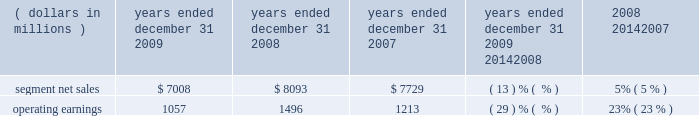Management 2019s discussion and analysis of financial condition and results of operations in 2008 , sales to the segment 2019s top five customers represented approximately 45% ( 45 % ) of the segment 2019s net sales .
The segment 2019s backlog was $ 2.3 billion at december 31 , 2008 , compared to $ 2.6 billion at december 31 , 2007 .
In 2008 , our digital video customers significantly increased their purchases of the segment 2019s products and services , primarily due to increased demand for digital entertainment devices , particularly ip and hd/dvr devices .
In february 2008 , the segment acquired the assets related to digital cable set-top products of zhejiang dahua digital technology co. , ltd and hangzhou image silicon ( known collectively as dahua digital ) , a developer , manufacturer and marketer of cable set-tops and related low-cost integrated circuits for the emerging chinese cable business .
The acquisition helped the segment strengthen its position in the rapidly growing cable market in china .
Enterprise mobility solutions segment the enterprise mobility solutions segment designs , manufactures , sells , installs and services analog and digital two-way radios , wireless lan and security products , voice and data communications products and systems for private networks , wireless broadband systems and end-to-end enterprise mobility solutions to a wide range of customers , including government and public safety agencies ( which , together with all sales to distributors of two-way communication products , are referred to as the 2018 2018government and public safety market 2019 2019 ) , as well as retail , energy and utilities , transportation , manufacturing , healthcare and other commercial customers ( which , collectively , are referred to as the 2018 2018commercial enterprise market 2019 2019 ) .
In 2009 , the segment 2019s net sales represented 32% ( 32 % ) of the company 2019s consolidated net sales , compared to 27% ( 27 % ) in 2008 and 21% ( 21 % ) in 2007 .
Years ended december 31 percent change ( dollars in millions ) 2009 2008 2007 2009 20142008 2008 20142007 .
Segment results 20142009 compared to 2008 in 2009 , the segment 2019s net sales were $ 7.0 billion , a decrease of 13% ( 13 % ) compared to net sales of $ 8.1 billion in 2008 .
The 13% ( 13 % ) decrease in net sales reflects a 21% ( 21 % ) decrease in net sales to the commercial enterprise market and a 10% ( 10 % ) decrease in net sales to the government and public safety market .
The decrease in net sales to the commercial enterprise market reflects decreased net sales in all regions .
The decrease in net sales to the government and public safety market was primarily driven by decreased net sales in emea , north america and latin america , partially offset by higher net sales in asia .
The segment 2019s overall net sales were lower in north america , emea and latin america and higher in asia the segment had operating earnings of $ 1.1 billion in 2009 , a decrease of 29% ( 29 % ) compared to operating earnings of $ 1.5 billion in 2008 .
The decrease in operating earnings was primarily due to a decrease in gross margin , driven by the 13% ( 13 % ) decrease in net sales and an unfavorable product mix .
Also contributing to the decrease in operating earnings was an increase in reorganization of business charges , relating primarily to higher employee severance costs .
These factors were partially offset by decreased sg&a expenses and r&d expenditures , primarily related to savings from cost-reduction initiatives .
As a percentage of net sales in 2009 as compared 2008 , gross margin decreased and r&d expenditures and sg&a expenses increased .
Net sales in north america continued to comprise a significant portion of the segment 2019s business , accounting for approximately 58% ( 58 % ) of the segment 2019s net sales in 2009 , compared to approximately 57% ( 57 % ) in 2008 .
The regional shift in 2009 as compared to 2008 reflects a 16% ( 16 % ) decline in net sales outside of north america and a 12% ( 12 % ) decline in net sales in north america .
The segment 2019s backlog was $ 2.4 billion at both december 31 , 2009 and december 31 , 2008 .
In our government and public safety market , we see a continued emphasis on mission-critical communication and homeland security solutions .
In 2009 , we led market innovation through the continued success of our mototrbo line and the delivery of the apx fffd family of products .
While spending by end customers in the segment 2019s government and public safety market is affected by government budgets at the national , state and local levels , we continue to see demand for large-scale mission critical communications systems .
In 2009 , we had significant wins across the globe , including several city and statewide communications systems in the united states , and continued success winning competitive projects with our tetra systems in europe , the middle east .
Did consolidated net sales grow from 2007 to 2009 and what was this growth in a percentage? 
Rationale: in order to find out the consolidated net sales one must multiple the segmented net sales by the percentage given in line 7 . we then subtract the two numbers and take the answer and divide by the lower number . this gives us 38.2% .
Computations: (((7008 * 32%) - (7729 * 21%)) / (7729 * 21%))
Answer: 0.38166. 